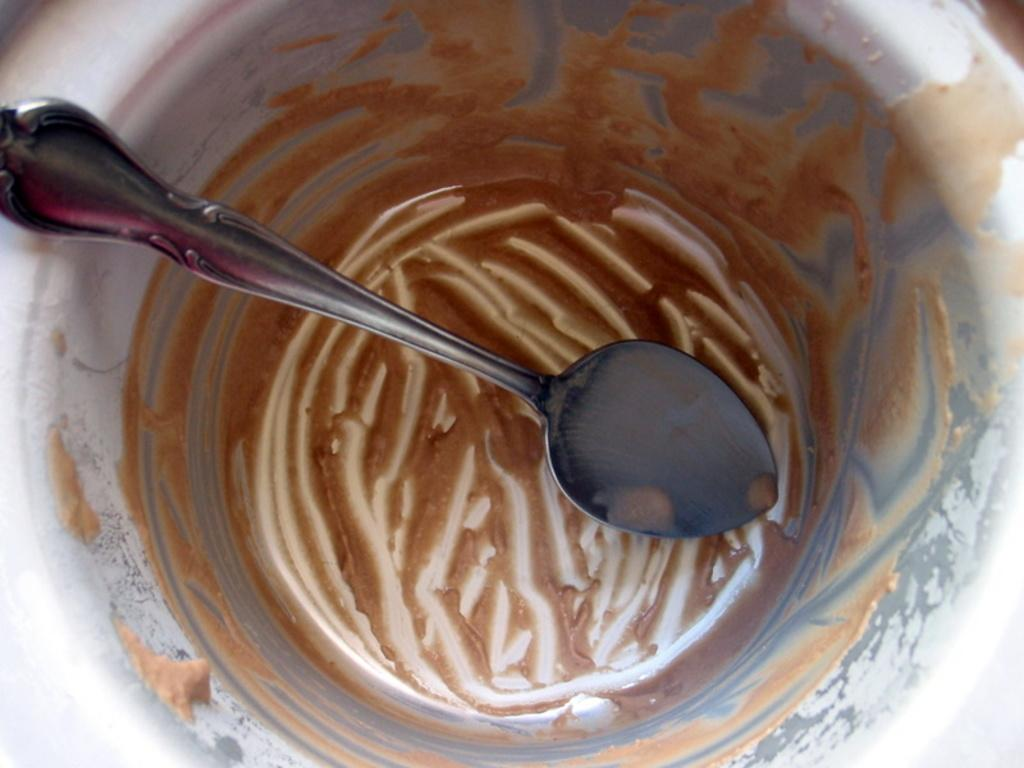What type of container is visible in the image? There is a metal container in the image. What is the color of the metal container? The metal container is ash in color. What can be found inside the metal container? There is a brown-colored object and a silver-colored spoon in the container. Is there a mask inside the metal container? No, there is no mask present in the image. 